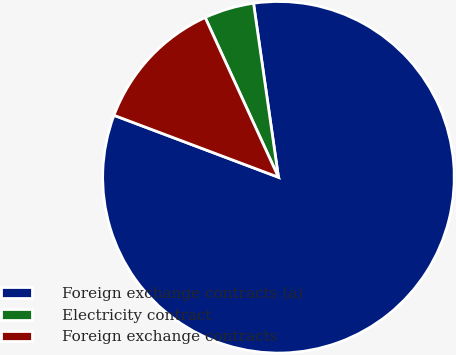<chart> <loc_0><loc_0><loc_500><loc_500><pie_chart><fcel>Foreign exchange contracts (a)<fcel>Electricity contract<fcel>Foreign exchange contracts<nl><fcel>83.0%<fcel>4.58%<fcel>12.42%<nl></chart> 